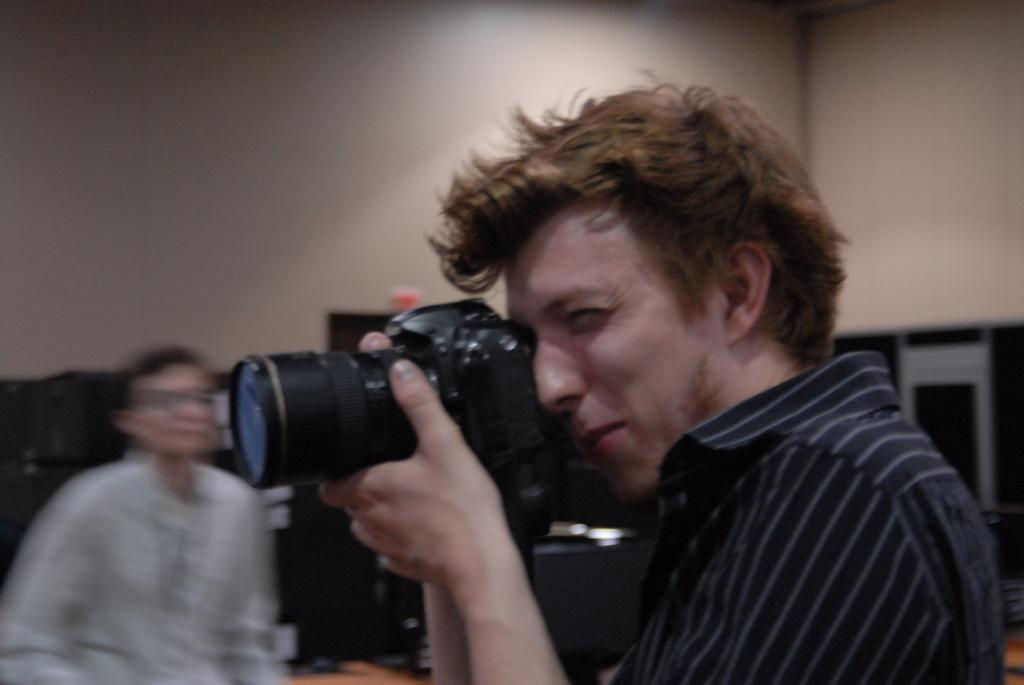Who is present in the image? There is a person in the image. What is the person wearing? The person is wearing a black T-shirt. What is the person holding in their hands? The person is holding a camera in their hands. What type of corn can be seen growing in the background of the image? There is no corn visible in the image; it only features a person wearing a black T-shirt and holding a camera. 